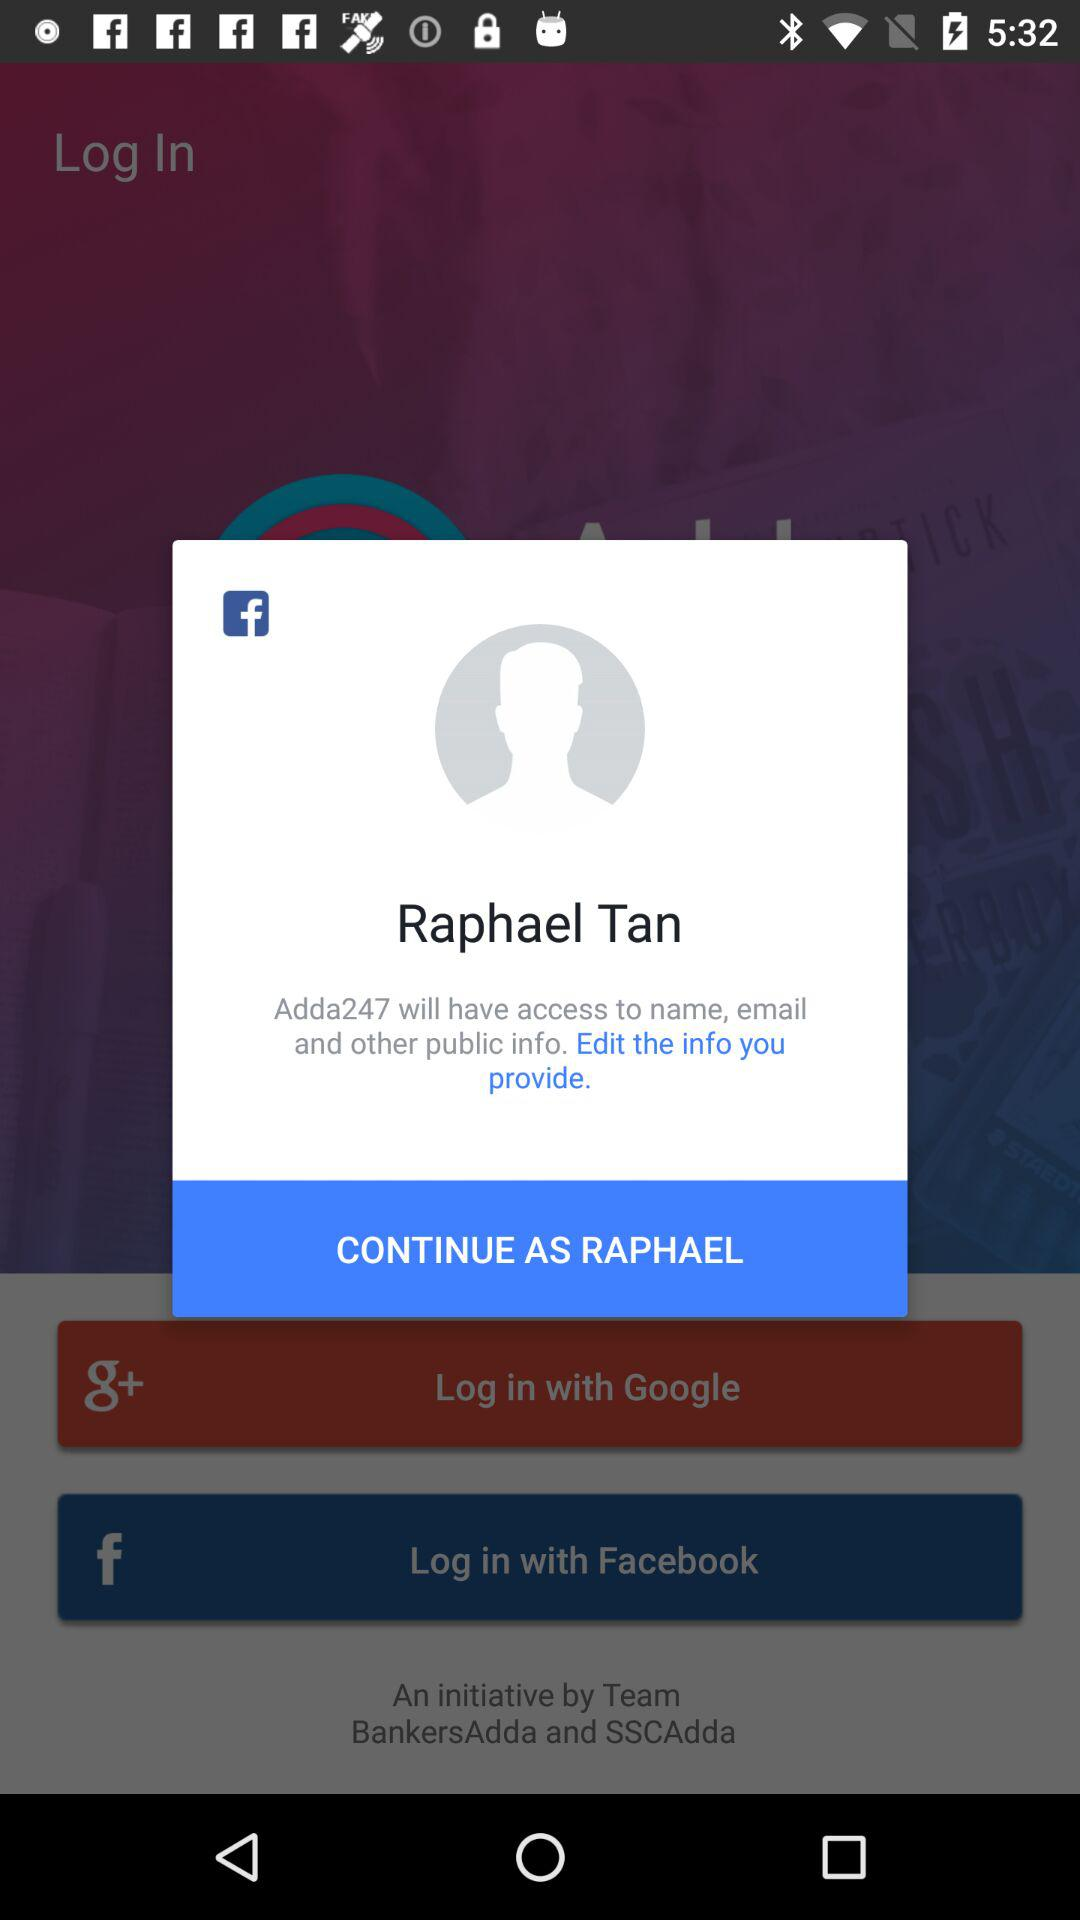What "Facebook" profile can we use for login? The profile that can be used for login is Raphael Tan. 